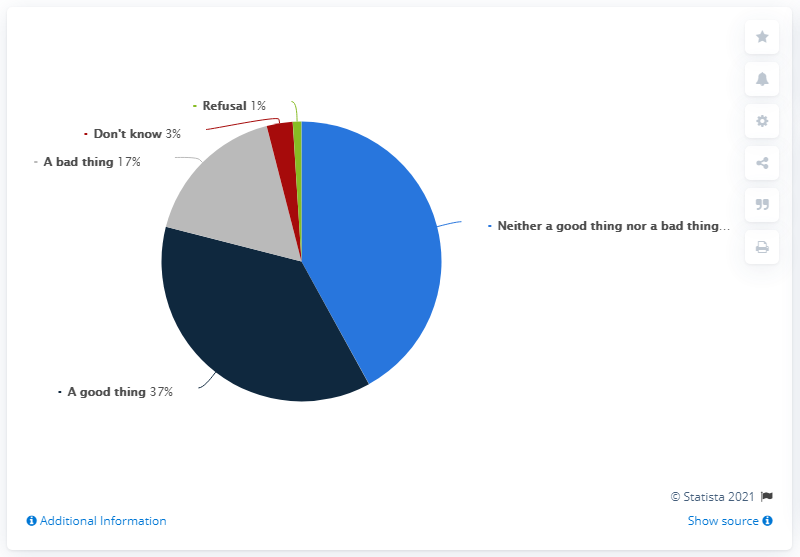Indicate a few pertinent items in this graphic. Out of the people surveyed, 3% responded with 'Don't know.' Which opinion is 20% less positive than 'A good thing'? A bad thing. 